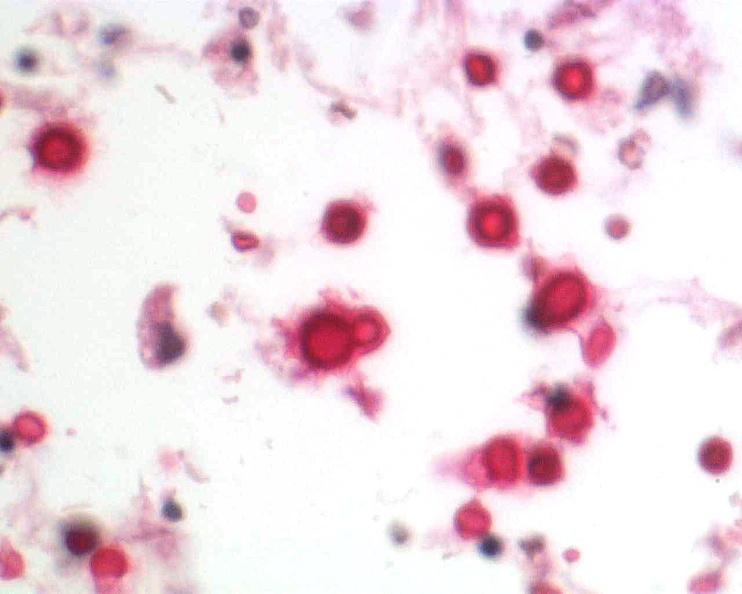s bone, mandible present?
Answer the question using a single word or phrase. No 